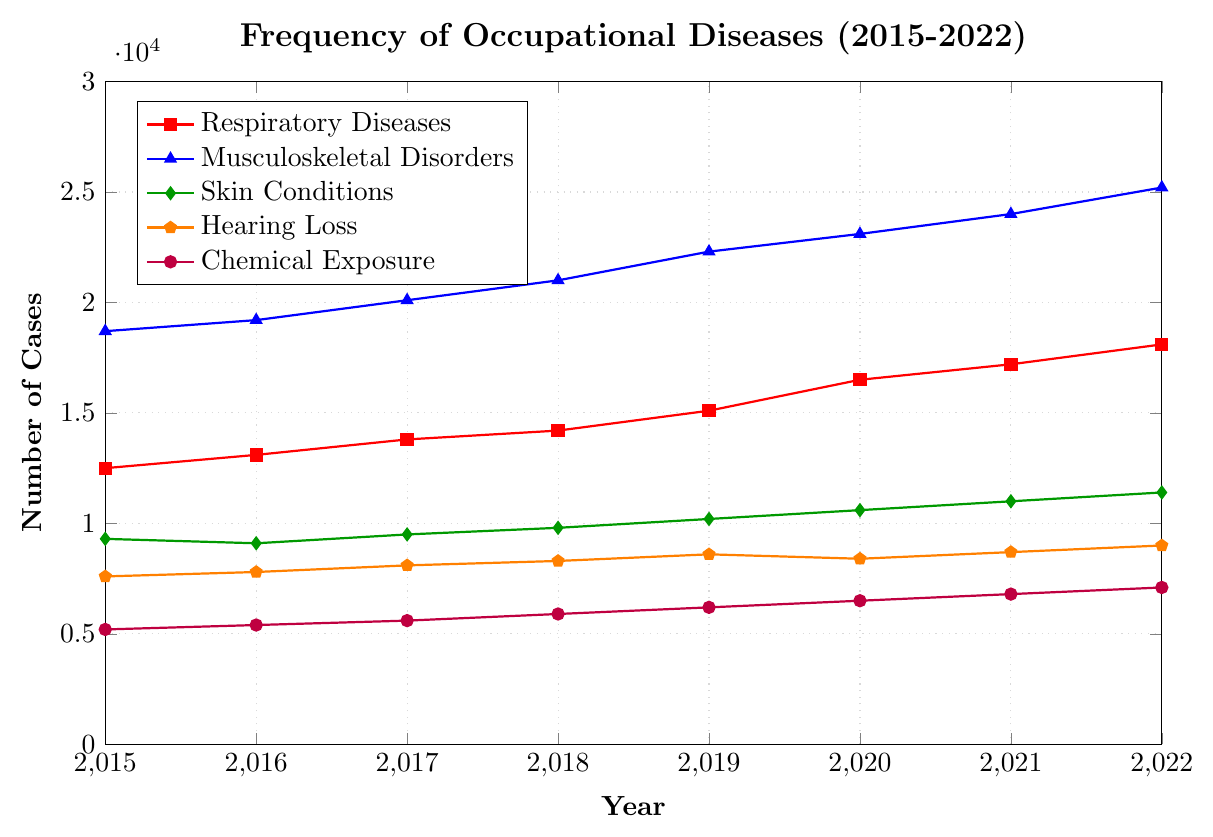Which type of occupational disease had the highest number of reported cases in 2022? In the figure, look at the endpoint value for the year 2022 for each category. Musculoskeletal Disorders had the highest endpoint of 25200 cases.
Answer: Musculoskeletal Disorders What is the difference in the number of cases between Respiratory Diseases and Chemical Exposure in 2015? Subtract the number of Chemical Exposure cases from Respiratory Diseases cases for the year 2015. 12500 - 5200 = 7300.
Answer: 7300 How did the frequency of Hearing Loss change from 2019 to 2020? Look at the values for Hearing Loss in 2019 and 2020. Compare them to see the change. 8600 in 2019 and 8400 in 2020, indicating a decrease by 8600 - 8400 = 200 cases.
Answer: Decreased by 200 What is the average number of Musculoskeletal Disorders reported per year over the period 2015-2022? Sum the values for Musculoskeletal Disorders from 2015 to 2022, then divide by the number of years (8). (18700 + 19200 + 20100 + 21000 + 22300 + 23100 + 24000 + 25200) / 8 = 21625.
Answer: 21625 Which type of occupational disease showed the most consistent linear increase over the period 2015-2022? Observe the trend lines for each category. The line for Musculoskeletal Disorders shows a consistent linear increase without significant fluctuations.
Answer: Musculoskeletal Disorders How many more Skin Conditions cases were there in 2022 compared to 2016? Subtract the number of Skin Conditions cases in 2016 from those in 2022. 11400 - 9100 = 2300.
Answer: 2300 Which disease had the lowest number of reported cases in 2018, and how many were there? Look at the values for each disease in 2018. Chemical Exposure had the lowest number with 5900 cases.
Answer: Chemical Exposure, 5900 What is the total number of reported cases for all types of diseases combined in the year 2020? Sum the values for all categories in 2020: 16500 + 23100 + 10600 + 8400 + 6500 = 65100.
Answer: 65100 What is the percentage increase in Respiratory Diseases cases from 2015 to 2022? Calculate the difference between the 2022 and 2015 values, then divide by the 2015 value and multiply by 100. ((18100 - 12500) / 12500) * 100 = 44.8%.
Answer: 44.8% Which occupational disease's trend line is depicted in blue on the plot? Identify the color associated with each disease in the legend. The blue line corresponds to Musculoskeletal Disorders.
Answer: Musculoskeletal Disorders 